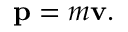Convert formula to latex. <formula><loc_0><loc_0><loc_500><loc_500>p = m v .</formula> 